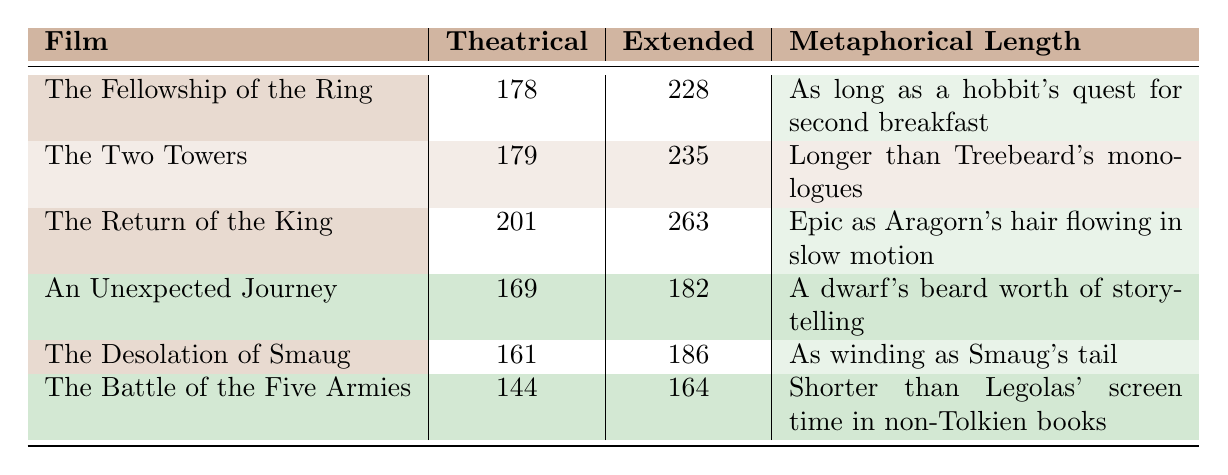What is the theatrical runtime of "The Fellowship of the Ring"? The table lists "The Fellowship of the Ring" with a theatrical runtime of 178 minutes.
Answer: 178 minutes Which film has the longest extended runtime? By comparing the extended runtimes, "The Return of the King" has the longest duration at 263 minutes.
Answer: "The Return of the King" Is the theatrical runtime of "The Desolation of Smaug" shorter than that of "The Two Towers"? "The Desolation of Smaug" has a theatrical runtime of 161 minutes, while "The Two Towers" has 179 minutes, which means "The Desolation of Smaug" is indeed shorter.
Answer: Yes What is the difference in extended runtime between "An Unexpected Journey" and "The Battle of the Five Armies"? "An Unexpected Journey" has an extended runtime of 182 minutes and "The Battle of the Five Armies" has 164 minutes. The difference is 182 - 164 = 18 minutes.
Answer: 18 minutes Calculate the average theatrical runtime of all the films. The theatrical runtimes are 178, 179, 201, 169, 161, and 144. Adding them gives 1032 minutes. There are 6 films; therefore, the average is 1032 / 6 = 172 minutes.
Answer: 172 minutes Which film is metaphorically described as "As winding as Smaug's tail"? The film that is metaphorically described this way is "The Desolation of Smaug," as mentioned in the Metaphorical Length column.
Answer: "The Desolation of Smaug" Is the theatrical runtime of "The Return of the King" greater than the average theatrical runtime of the films? The average theatrical runtime, calculated previously as 172 minutes, is less than "The Return of the King," which has a runtime of 201 minutes.
Answer: Yes What is the total theatrical runtime for all the films combined? The total theatrical runtime is the sum of individual runtimes: 178 + 179 + 201 + 169 + 161 + 144 = 1032 minutes.
Answer: 1032 minutes Which film's metaphorical length implies it's shorter than "Legolas' screen time in non-Tolkien books"? The metaphorical length for "The Battle of the Five Armies" suggests it’s shorter than Legolas' screen time, as noted in the table.
Answer: "The Battle of the Five Armies" What is the extended runtime of "The Two Towers"? According to the table, "The Two Towers" has an extended runtime of 235 minutes.
Answer: 235 minutes 